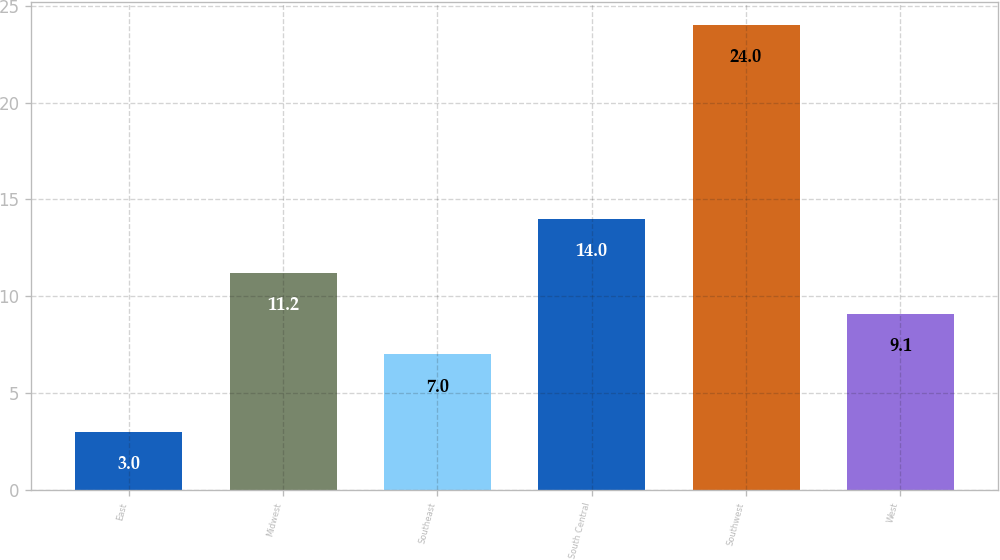Convert chart. <chart><loc_0><loc_0><loc_500><loc_500><bar_chart><fcel>East<fcel>Midwest<fcel>Southeast<fcel>South Central<fcel>Southwest<fcel>West<nl><fcel>3<fcel>11.2<fcel>7<fcel>14<fcel>24<fcel>9.1<nl></chart> 